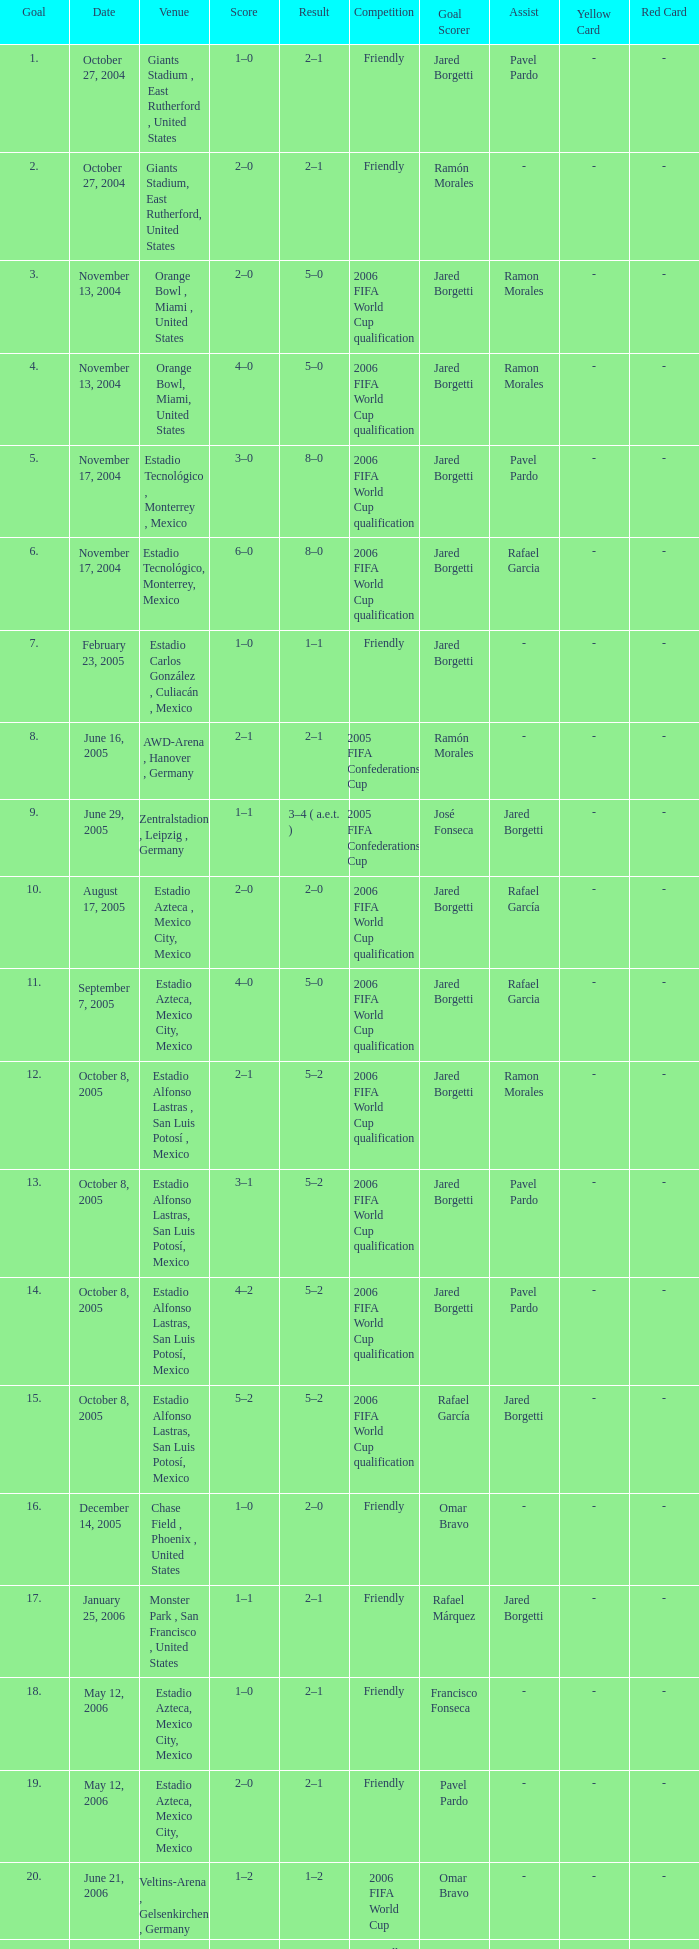Which Score has a Result of 2–1, and a Competition of friendly, and a Goal smaller than 17? 1–0, 2–0. 